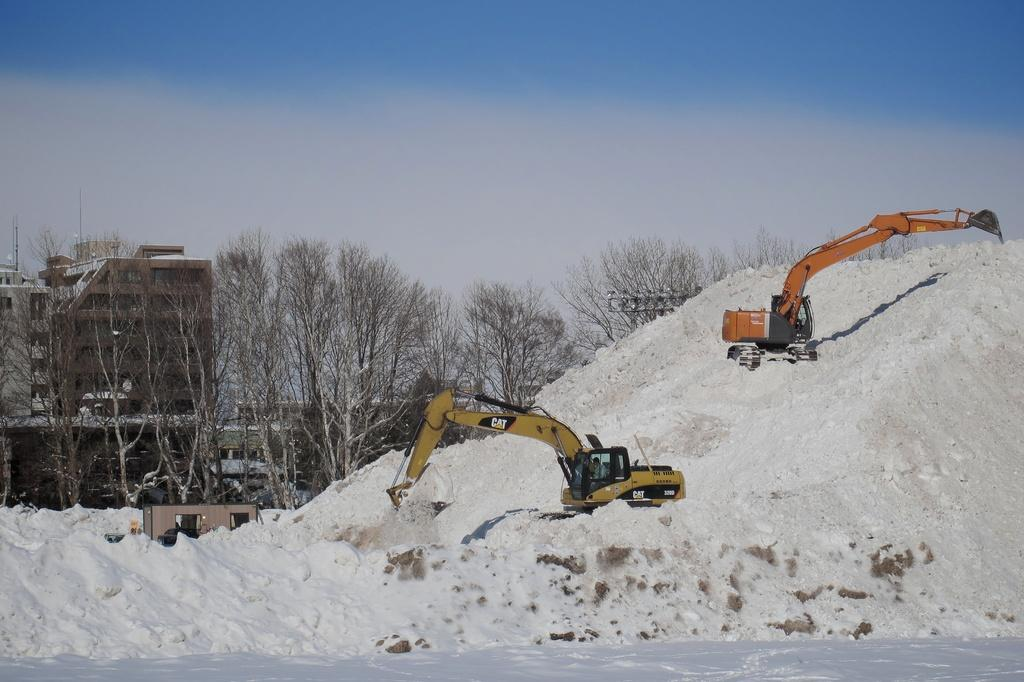What type of weather is depicted in the image? There is snow at the bottom of the image, indicating a winter scene. What can be seen in the foreground of the image? There are people and proclaimers in the foreground of the image. What is visible in the background of the image? There are trees and buildings in the background of the image. What is visible at the top of the image? The sky is visible at the top of the image. What type of metal is used to make the trousers worn by the people in the image? There is no mention of metal or trousers in the image; the focus is on the snow, people, proclaimers, trees, buildings, and sky. 